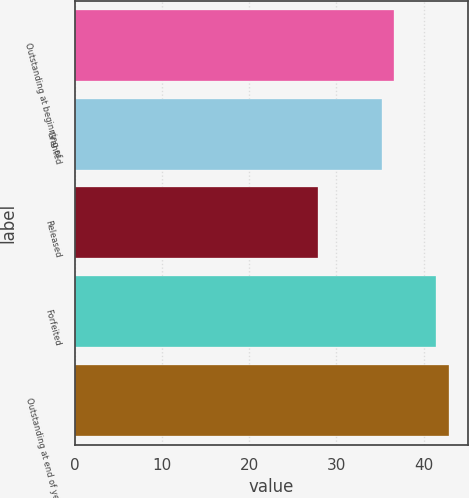Convert chart to OTSL. <chart><loc_0><loc_0><loc_500><loc_500><bar_chart><fcel>Outstanding at beginning of<fcel>Granted<fcel>Released<fcel>Forfeited<fcel>Outstanding at end of year<nl><fcel>36.61<fcel>35.17<fcel>27.9<fcel>41.46<fcel>42.9<nl></chart> 